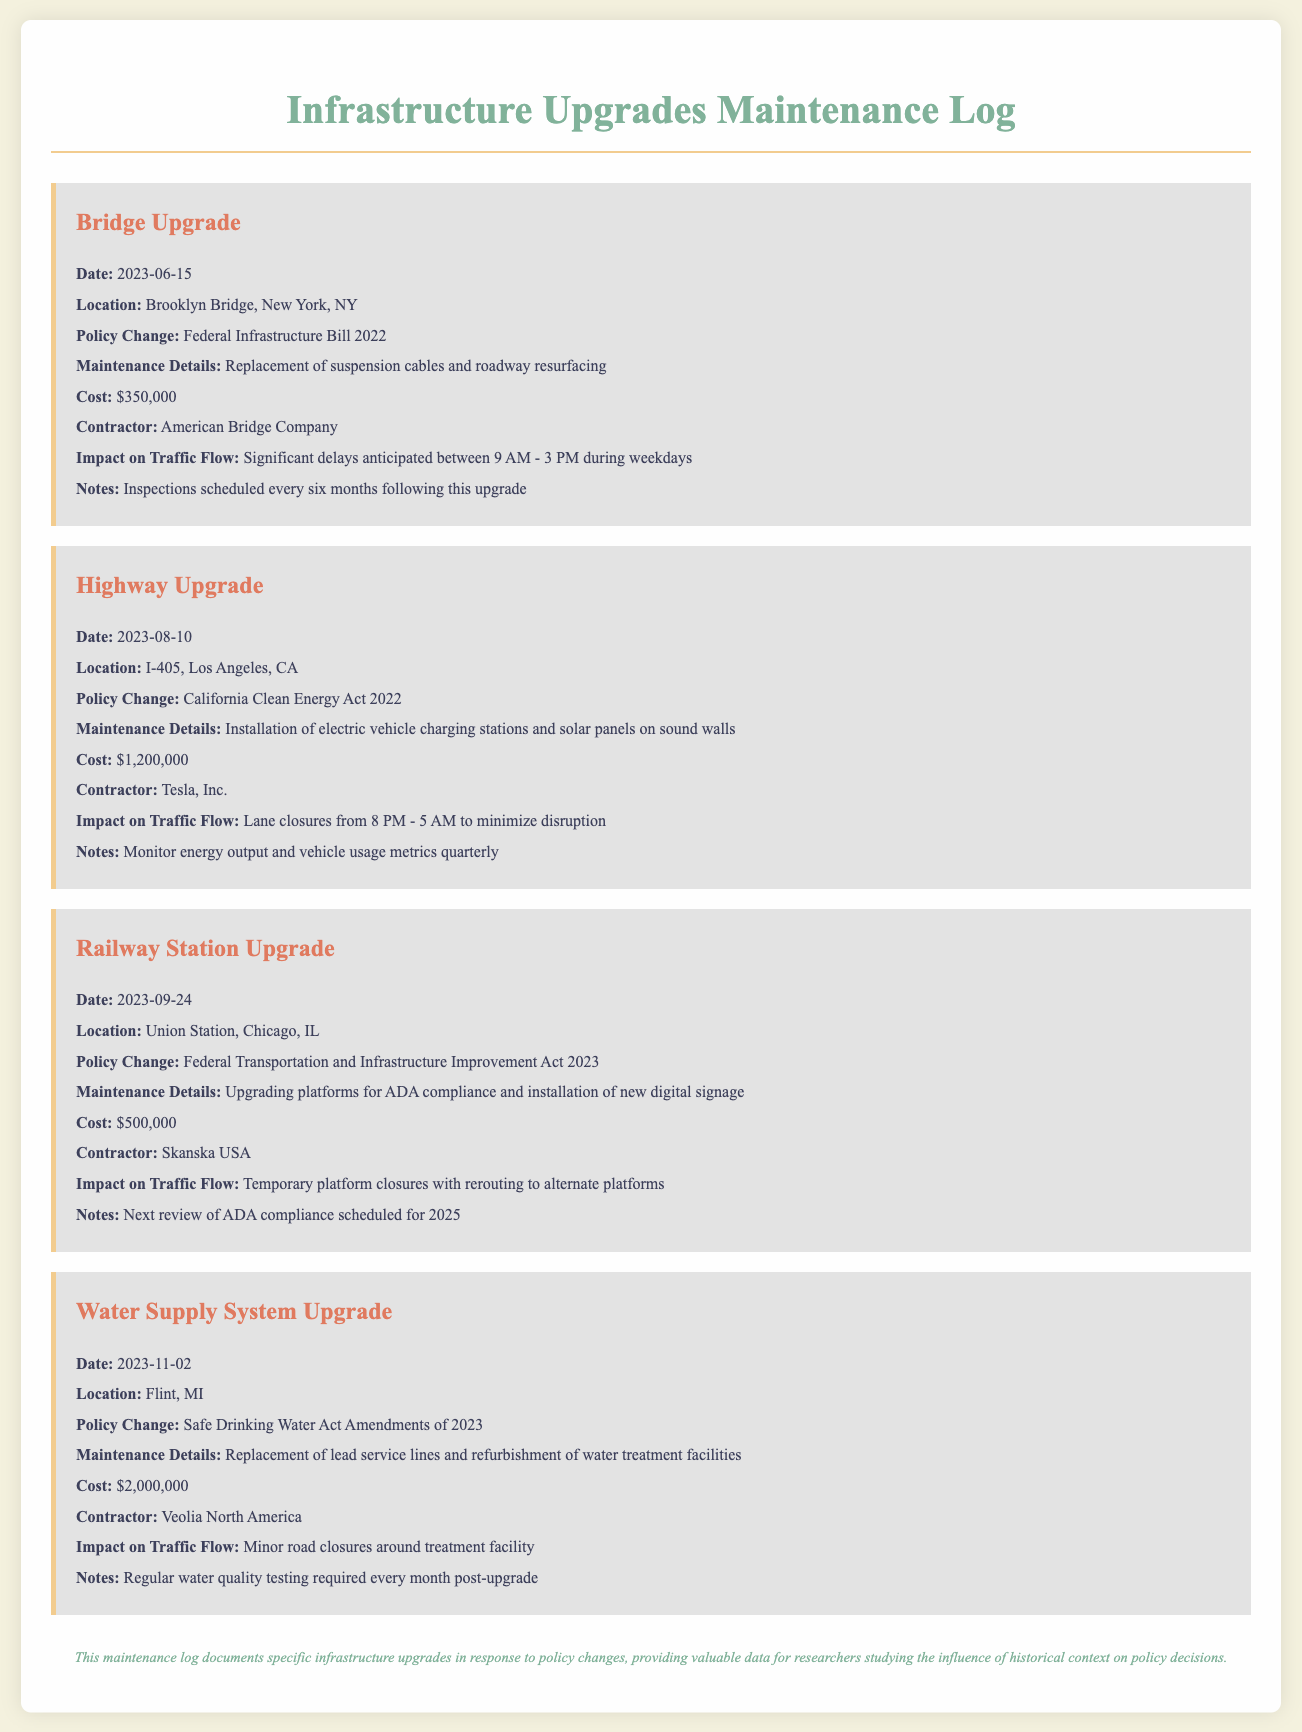what was the date of the Bridge upgrade? The date is provided in the log entry for the Bridge Upgrade section.
Answer: 2023-06-15 who was the contractor for the Highway Upgrade? The contractor's name is listed in the Highway Upgrade log entry.
Answer: Tesla, Inc what was the cost of the Water Supply System Upgrade? The cost is specified directly in the log entry for the Water Supply System Upgrade.
Answer: $2,000,000 what specific policy change prompted the Railway Station Upgrade? The policy change is noted as part of the Railway Station Upgrade entry.
Answer: Federal Transportation and Infrastructure Improvement Act 2023 what type of maintenance was performed during the Bridge Upgrade? The type of maintenance performed is detailed in the corresponding log entry.
Answer: Replacement of suspension cables and roadway resurfacing what measures are being taken for traffic during the Highway Upgrade? The information related to traffic impact during the highway maintenance can be found in the upgrade entry.
Answer: Lane closures from 8 PM - 5 AM how often will water quality testing occur after the Water Supply System Upgrade? The frequency of water quality testing is specified in the log entry regarding this upgrade.
Answer: Every month what is unique about the Railway Station Upgrade compared to the Bridge and Highway upgrades? This entry requires understanding the context within the log regarding ADA compliance as part of the Railway Station upgrades.
Answer: Upgrading platforms for ADA compliance what documentation is suggested to be done after the Bridge Upgrade? The suggested follow-up actions are mentioned in the log entry for the Bridge Upgrade.
Answer: Inspections scheduled every six months following this upgrade 